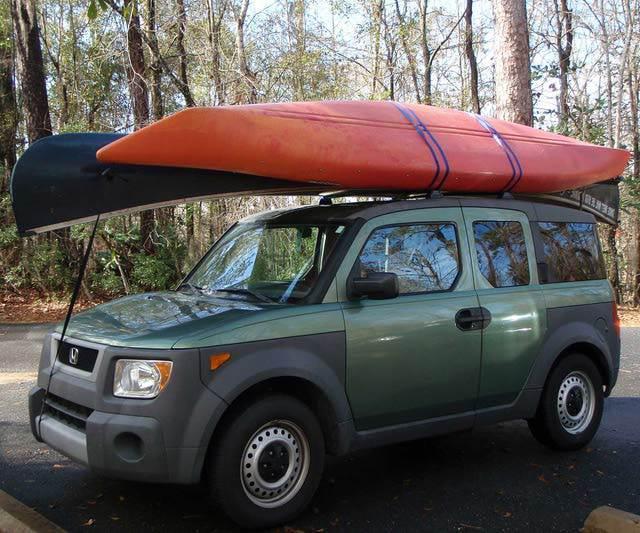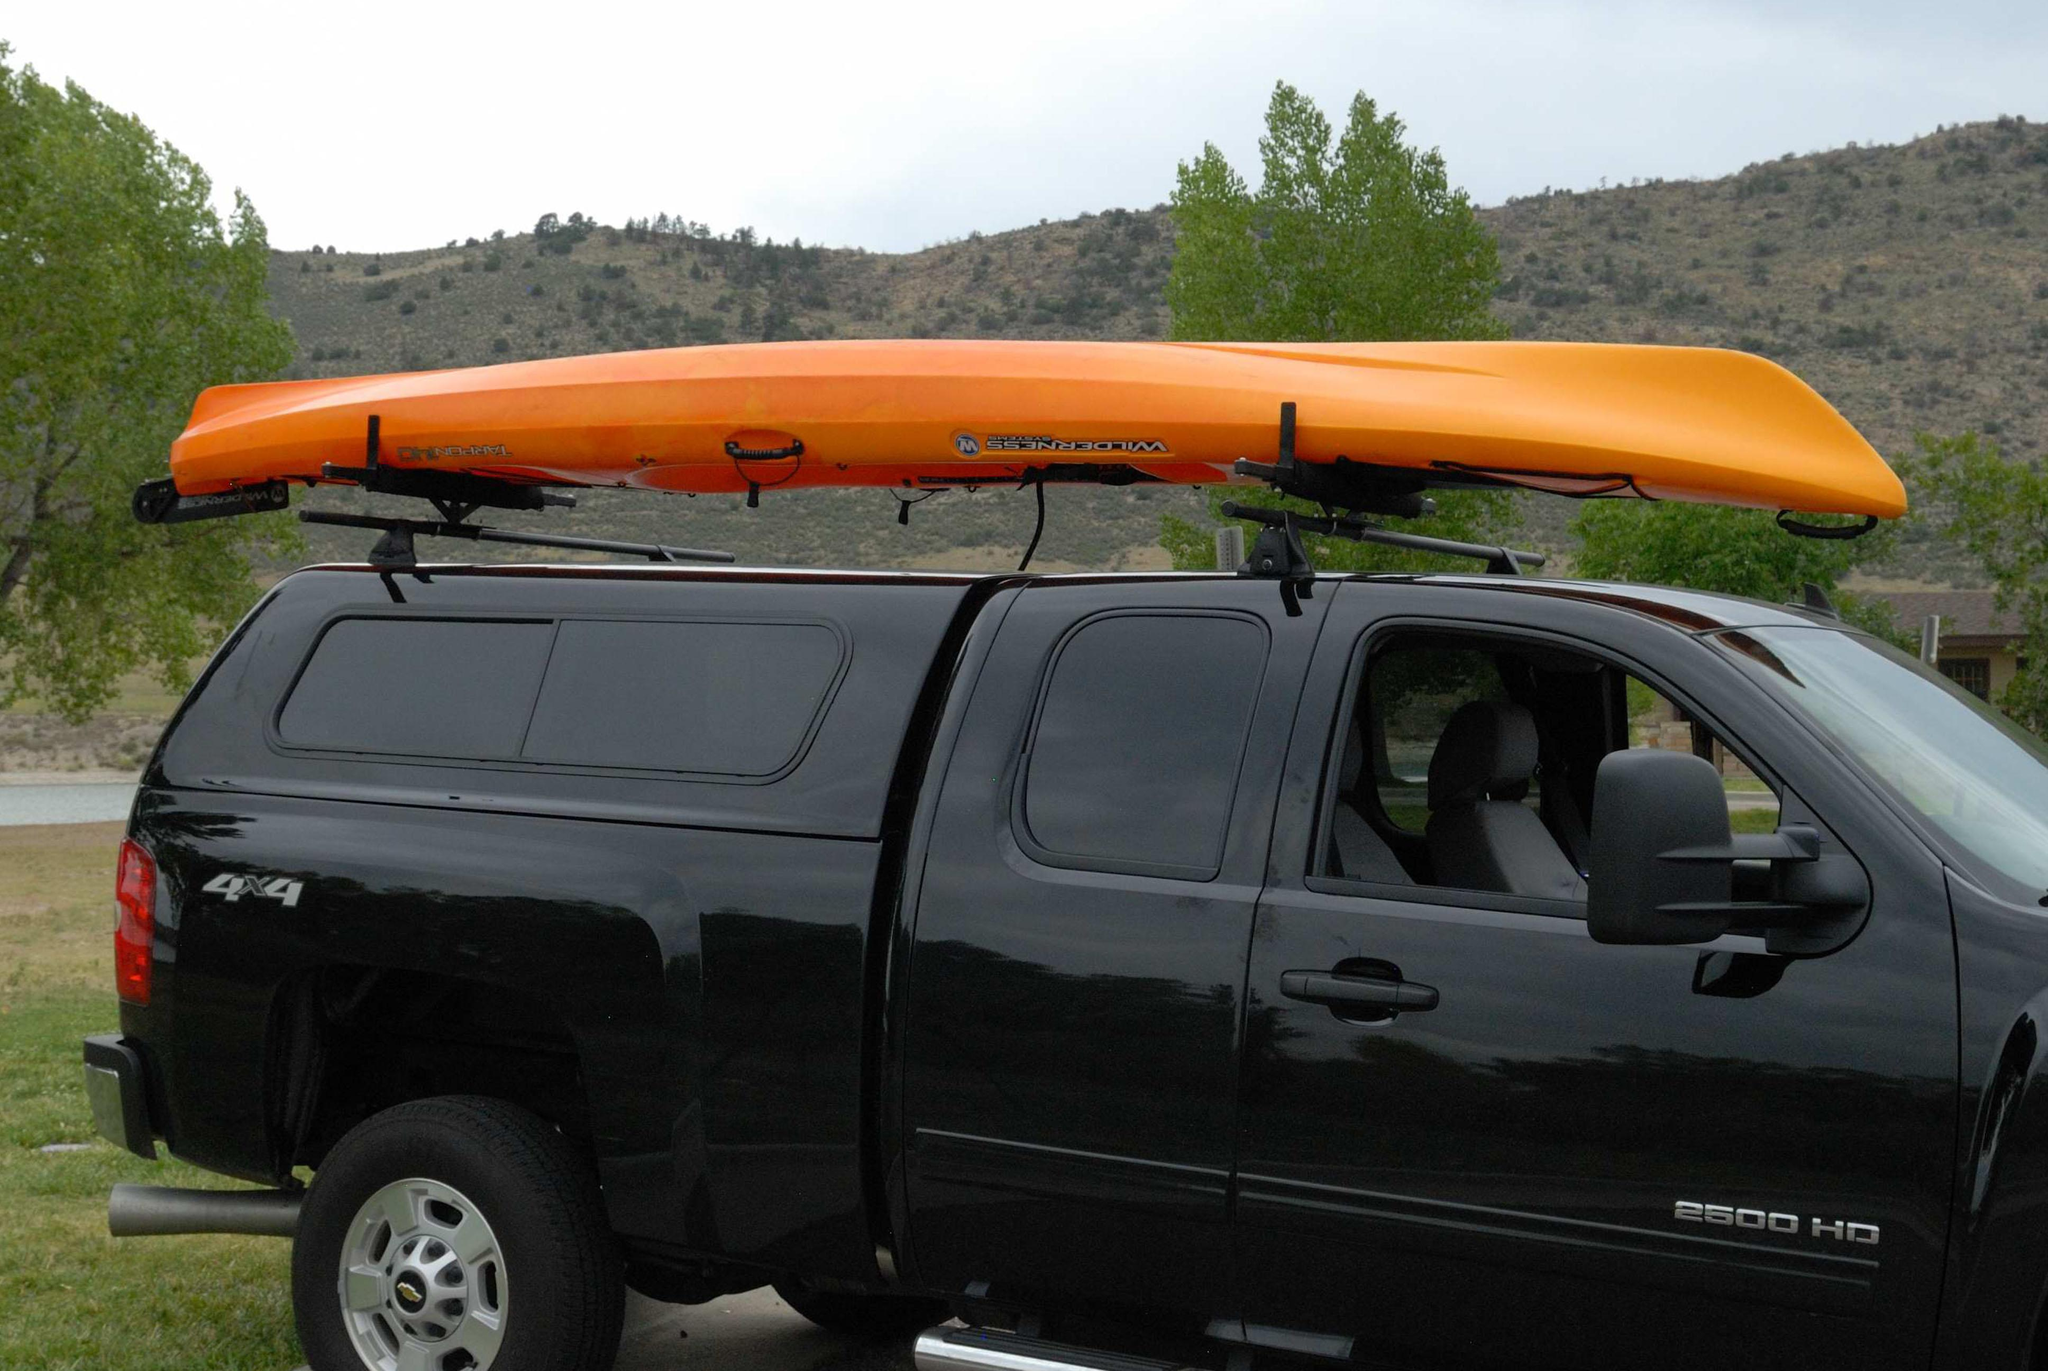The first image is the image on the left, the second image is the image on the right. Assess this claim about the two images: "A vehicle in one image is loaded with more than one boat.". Correct or not? Answer yes or no. Yes. 